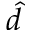<formula> <loc_0><loc_0><loc_500><loc_500>\hat { d }</formula> 